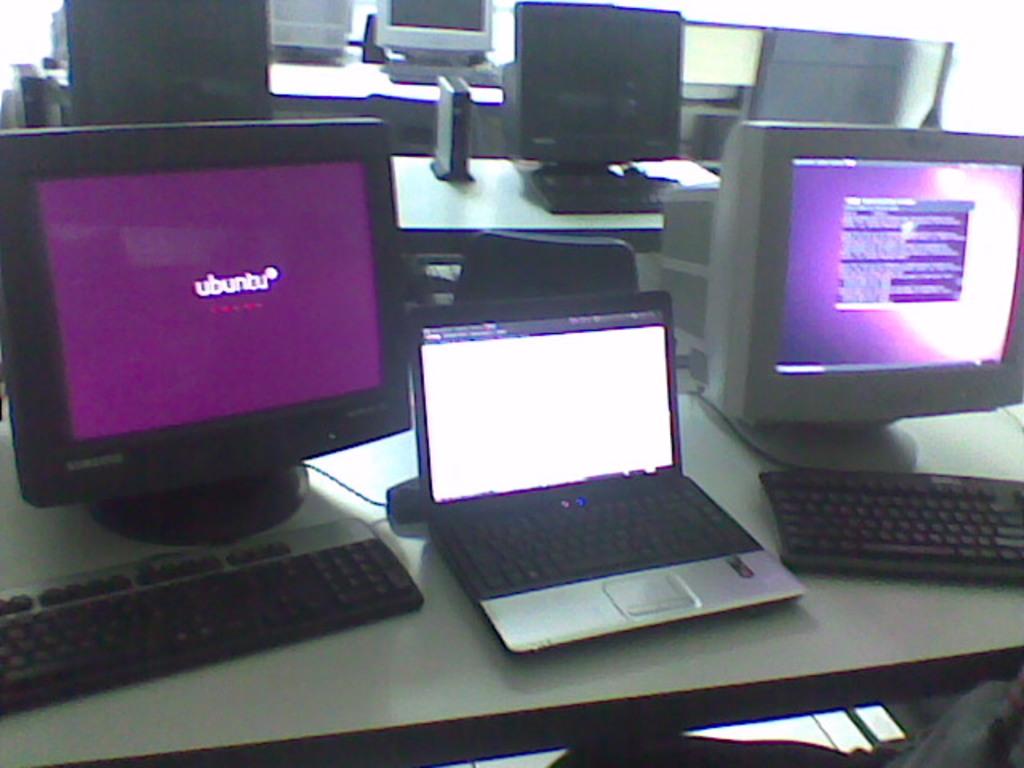What operating system is loading up?
Your answer should be very brief. Ubuntu. What is on the left monitor?
Offer a terse response. Ubuntu. 